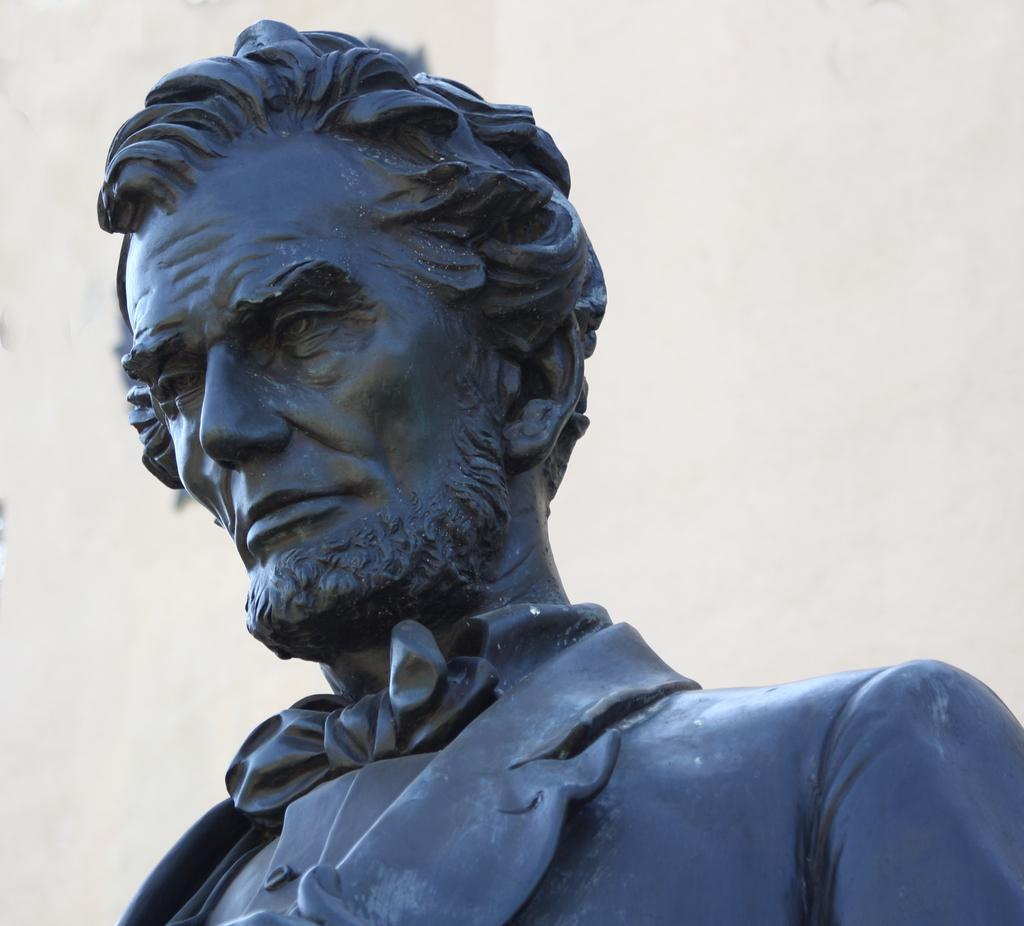What is the main subject of the image? There is a statue in the image. What type of art is being created in the notebook near the statue? There is no notebook present in the image, and therefore no art being created near the statue. 